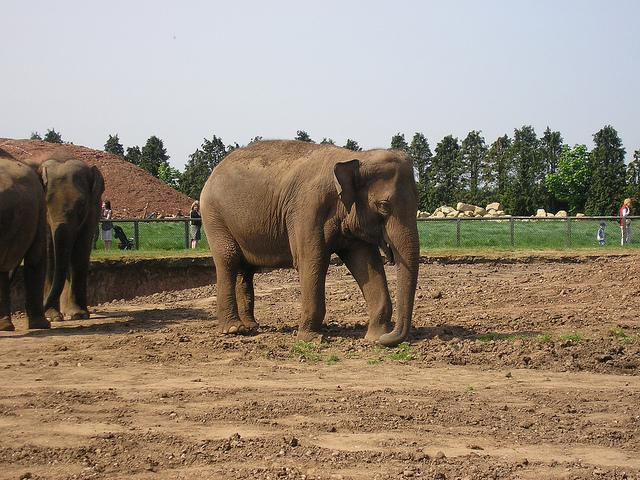Why do people gather outside the fence? watch elephants 